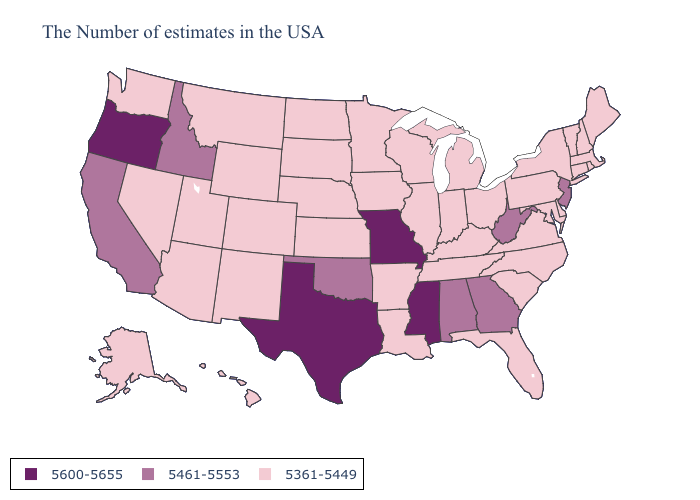Does Wisconsin have the same value as New Jersey?
Quick response, please. No. What is the highest value in the South ?
Concise answer only. 5600-5655. Does Vermont have a lower value than Rhode Island?
Give a very brief answer. No. Does Oregon have the lowest value in the USA?
Write a very short answer. No. Does Texas have the highest value in the USA?
Be succinct. Yes. What is the value of North Carolina?
Answer briefly. 5361-5449. What is the value of Vermont?
Concise answer only. 5361-5449. Does North Carolina have a higher value than South Dakota?
Write a very short answer. No. Does the first symbol in the legend represent the smallest category?
Quick response, please. No. What is the value of Minnesota?
Concise answer only. 5361-5449. Does Texas have the highest value in the USA?
Concise answer only. Yes. What is the highest value in states that border Iowa?
Quick response, please. 5600-5655. What is the value of Ohio?
Quick response, please. 5361-5449. Among the states that border Oregon , does Idaho have the lowest value?
Short answer required. No. 